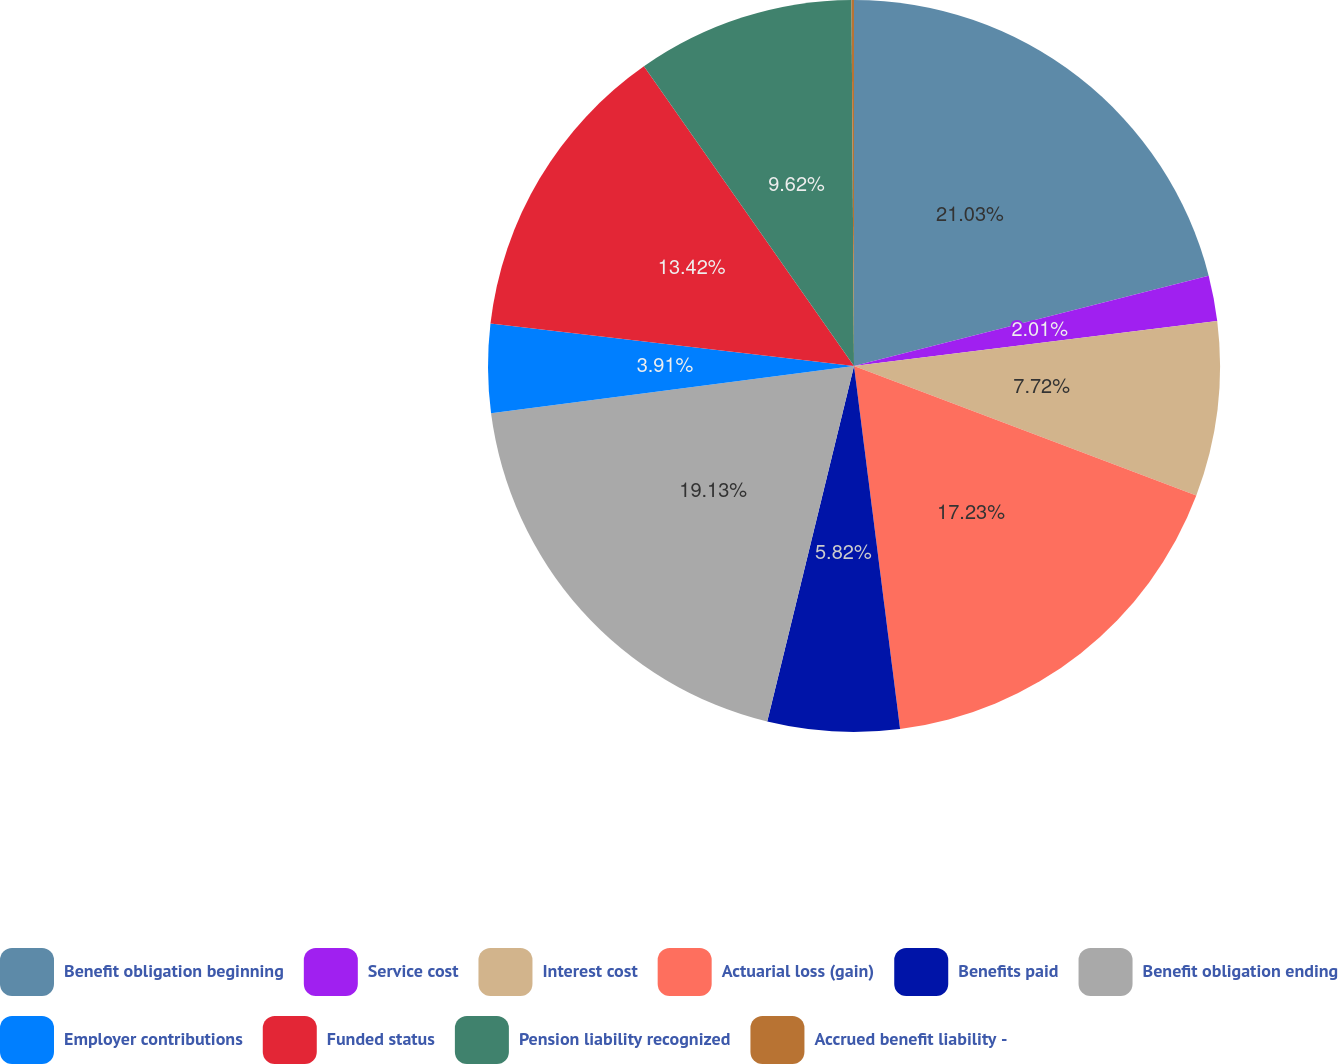Convert chart. <chart><loc_0><loc_0><loc_500><loc_500><pie_chart><fcel>Benefit obligation beginning<fcel>Service cost<fcel>Interest cost<fcel>Actuarial loss (gain)<fcel>Benefits paid<fcel>Benefit obligation ending<fcel>Employer contributions<fcel>Funded status<fcel>Pension liability recognized<fcel>Accrued benefit liability -<nl><fcel>21.03%<fcel>2.01%<fcel>7.72%<fcel>17.23%<fcel>5.82%<fcel>19.13%<fcel>3.91%<fcel>13.42%<fcel>9.62%<fcel>0.11%<nl></chart> 